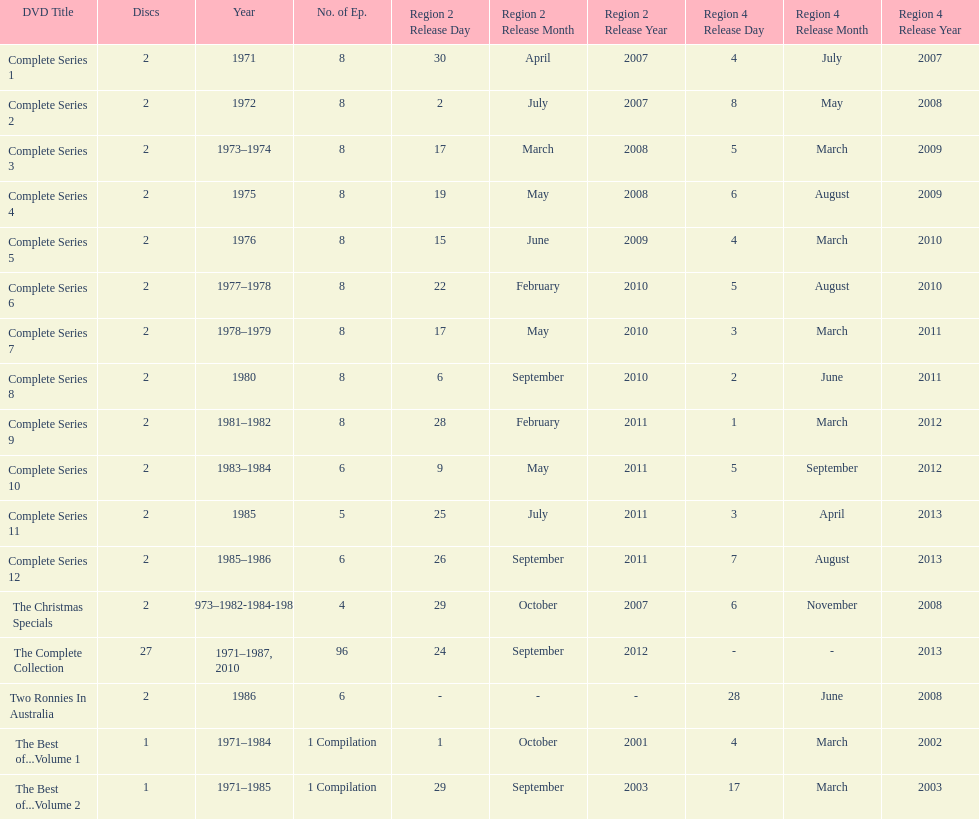How many "best of" volumes compile the top episodes of the television show "the two ronnies". 2. 